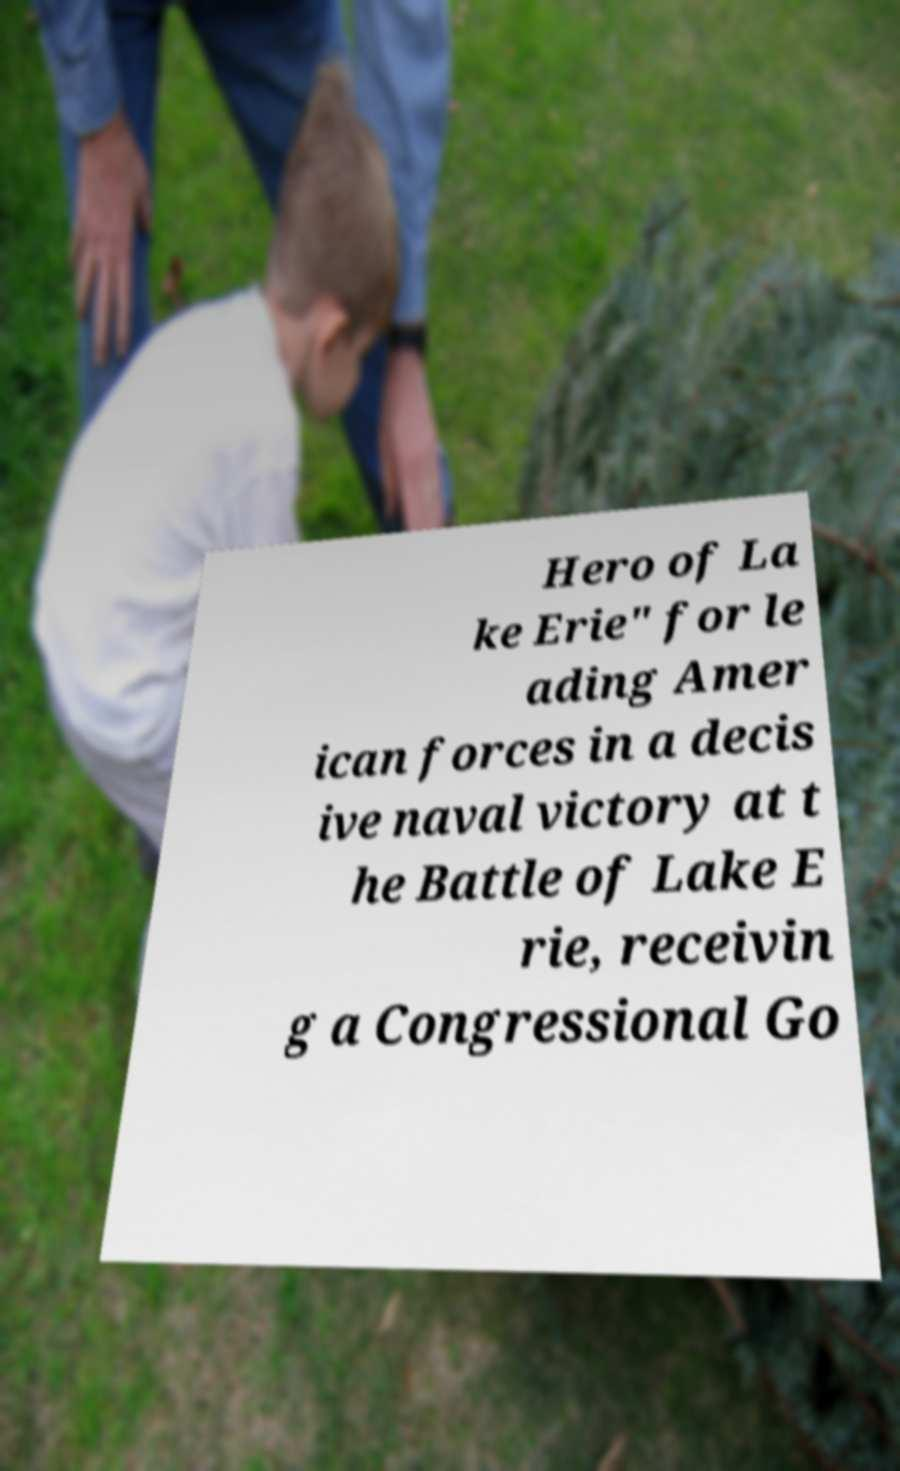Could you extract and type out the text from this image? Hero of La ke Erie" for le ading Amer ican forces in a decis ive naval victory at t he Battle of Lake E rie, receivin g a Congressional Go 